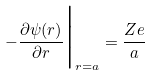Convert formula to latex. <formula><loc_0><loc_0><loc_500><loc_500>- \frac { \partial \psi ( { r } ) } { \partial r } \Big | _ { r = a } = \frac { Z e } { a }</formula> 